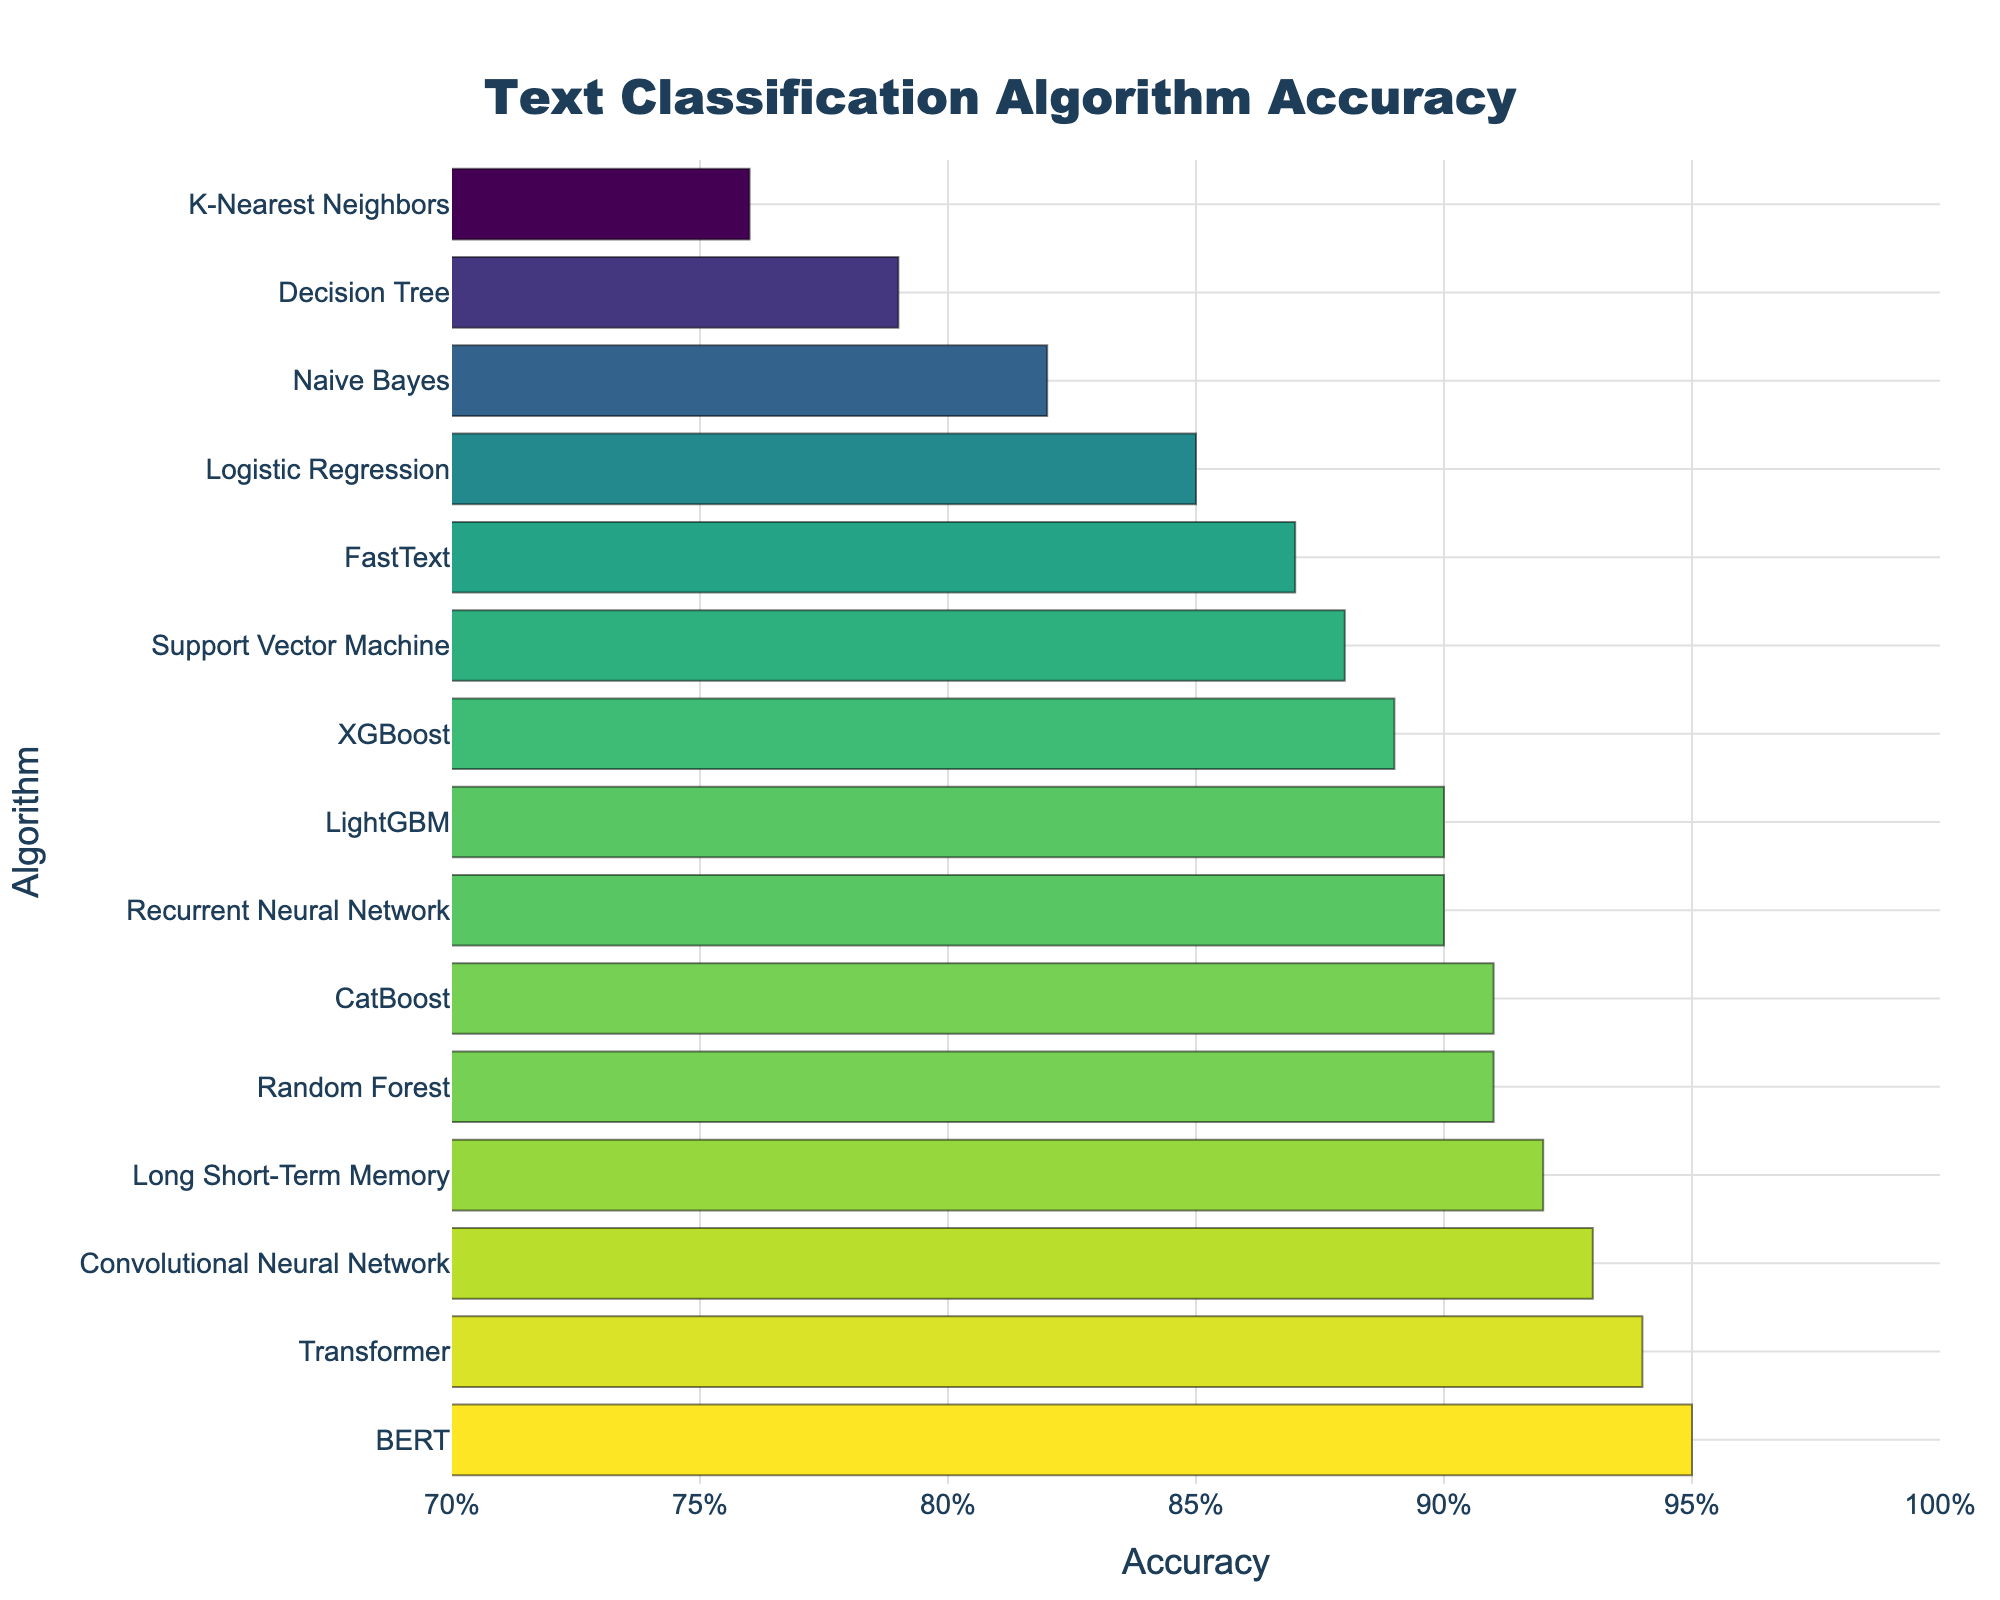Which algorithm has the highest accuracy? By examining the bar chart, we can see that BERT has the highest bar, indicating the highest accuracy rate among the algorithms.
Answer: BERT Which algorithm has the lowest accuracy? By looking at the bar chart, we can see that K-Nearest Neighbors has the shortest bar, indicating the lowest accuracy rate among the algorithms.
Answer: K-Nearest Neighbors What is the difference in accuracy between the algorithm with the highest accuracy and the algorithm with the lowest accuracy? The highest accuracy is 0.95 (BERT) and the lowest is 0.76 (K-Nearest Neighbors). Subtracting the lowest from the highest, 0.95 - 0.76, gives the accuracy difference.
Answer: 0.19 Which algorithms have an accuracy rate greater than 0.90? By examining the bar chart, the algorithms with bars extending beyond the 0.90 mark are Random Forest, Convolutional Neural Network, Recurrent Neural Network, Long Short-Term Memory, Transformer, CatBoost, and BERT.
Answer: Random Forest, Convolutional Neural Network, Recurrent Neural Network, Long Short-Term Memory, Transformer, CatBoost, BERT What is the average accuracy rate of the listed algorithms? Summing all accuracy rates provided (0.82 + 0.88 + 0.91 + 0.85 + 0.93 + 0.90 + 0.95 + 0.89 + 0.79 + 0.76 + 0.92 + 0.94 + 0.87 + 0.90 + 0.91) equals 13.12. Dividing this sum by the number of algorithms (15) results in the average accuracy rate.
Answer: 0.8747 How many algorithms have an accuracy rate below 0.80? By examining the shorter bars in the chart, the algorithms with accuracy rates below 0.80 are Decision Tree and K-Nearest Neighbors, resulting in a count of two.
Answer: Two What is the median accuracy rate of the listed algorithms? Sorting the accuracy rates, the median value is the one in the middle of this ordered list: (0.76, 0.79, 0.82, 0.85, 0.87, 0.88, 0.89, 0.90, 0.90, 0.91, 0.91, 0.92, 0.93, 0.94, 0.95). The median is the 8th value, which is 0.90.
Answer: 0.90 Which algorithm shows a notable improvement in accuracy compared to Naive Bayes? By comparing the accuracy rates, significant improvements are seen in algorithms like Support Vector Machine (0.88), Random Forest (0.91), Convolutional Neural Network (0.93), Recurrent Neural Network (0.90), Long Short-Term Memory (0.92), Transformer (0.94), CatBoost (0.91), and BERT (0.95). Each of these has at least 0.06 higher accuracy than Naive Bayes (0.82).
Answer: Support Vector Machine, Random Forest, Convolutional Neural Network, Recurrent Neural Network, Long Short-Term Memory, Transformer, CatBoost, BERT 